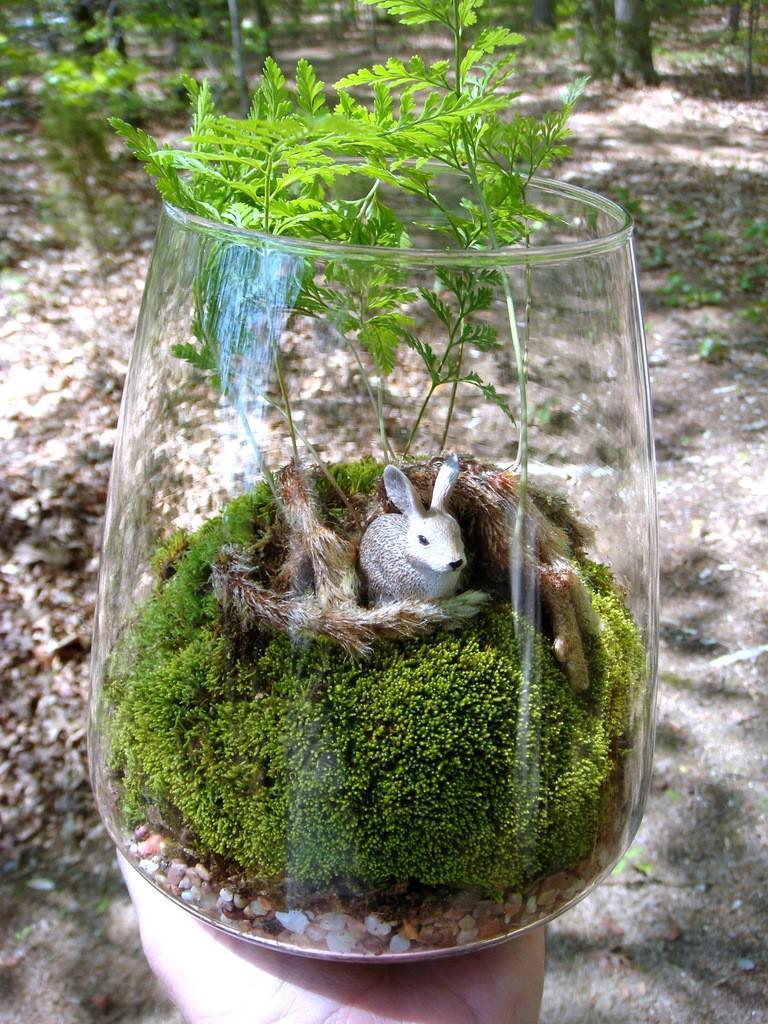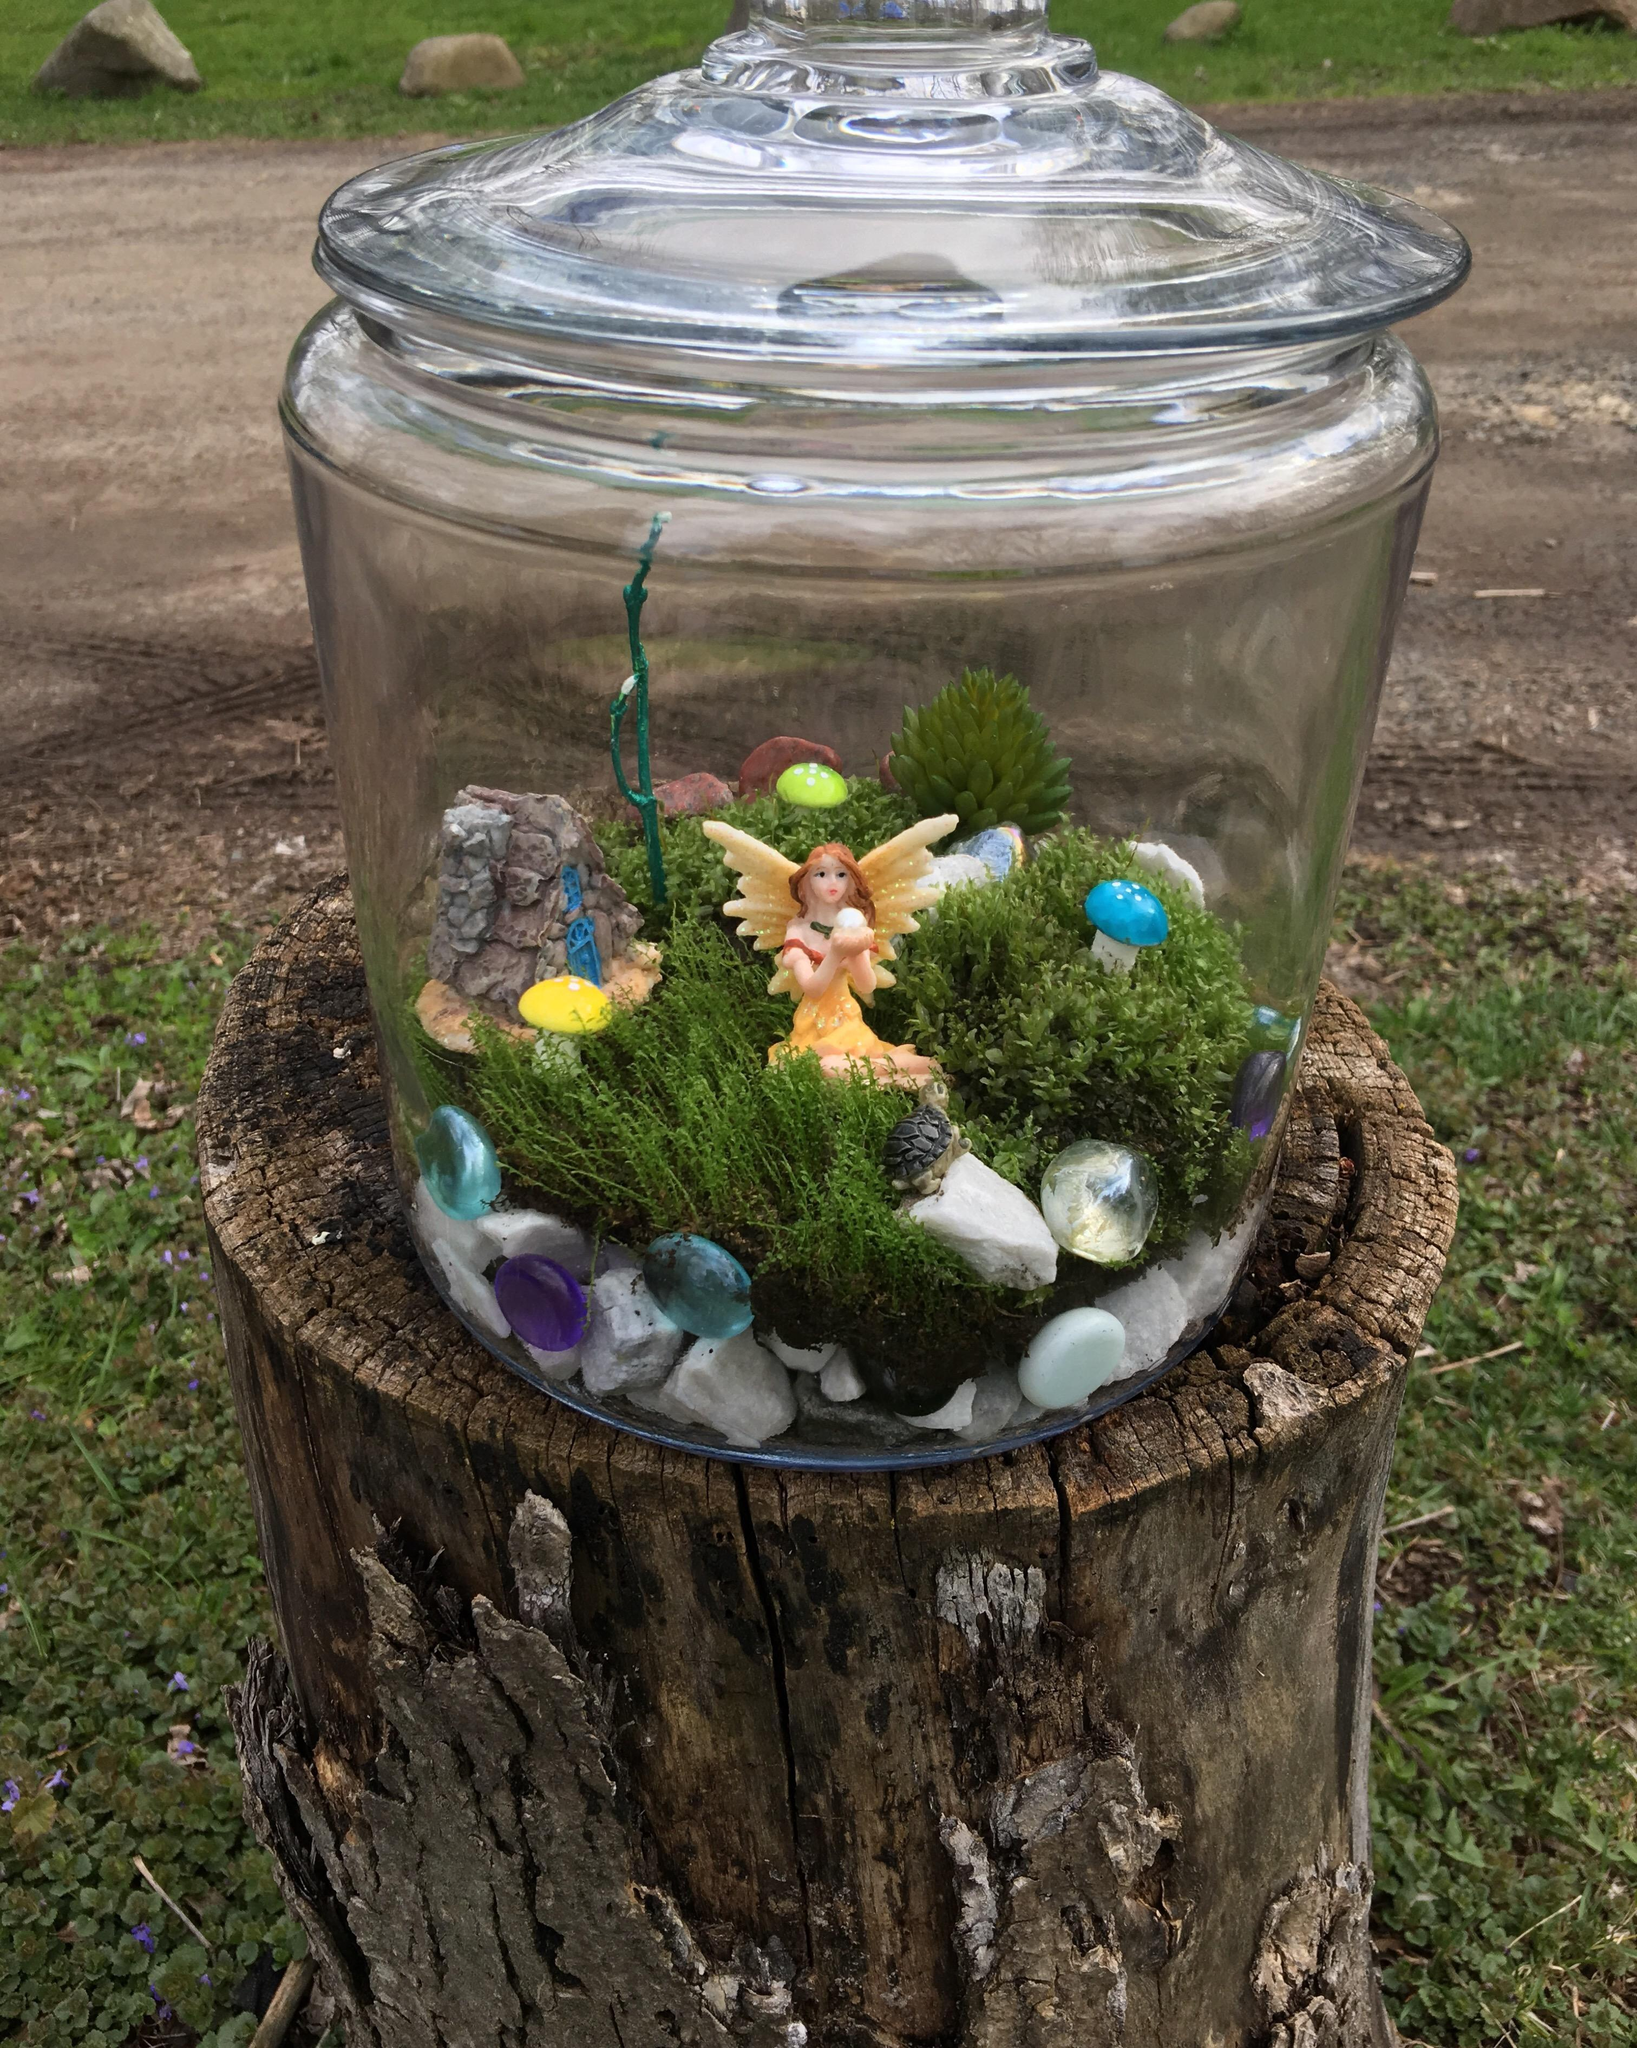The first image is the image on the left, the second image is the image on the right. Given the left and right images, does the statement "The right image features a 'fairy garden' terrarium shaped like a fishbowl on its side." hold true? Answer yes or no. No. The first image is the image on the left, the second image is the image on the right. Given the left and right images, does the statement "In at least on image there is a glass container holding a single sitting female fairy with wings." hold true? Answer yes or no. Yes. 